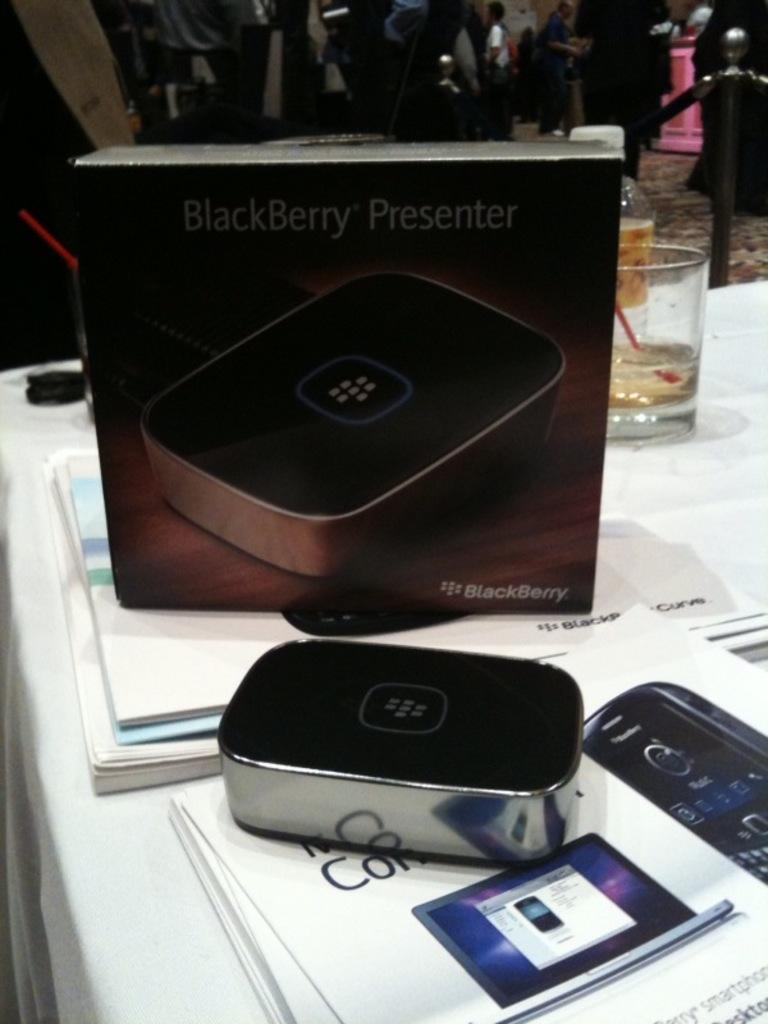Provide a one-sentence caption for the provided image. a Blackberry presenter that is in a box. 